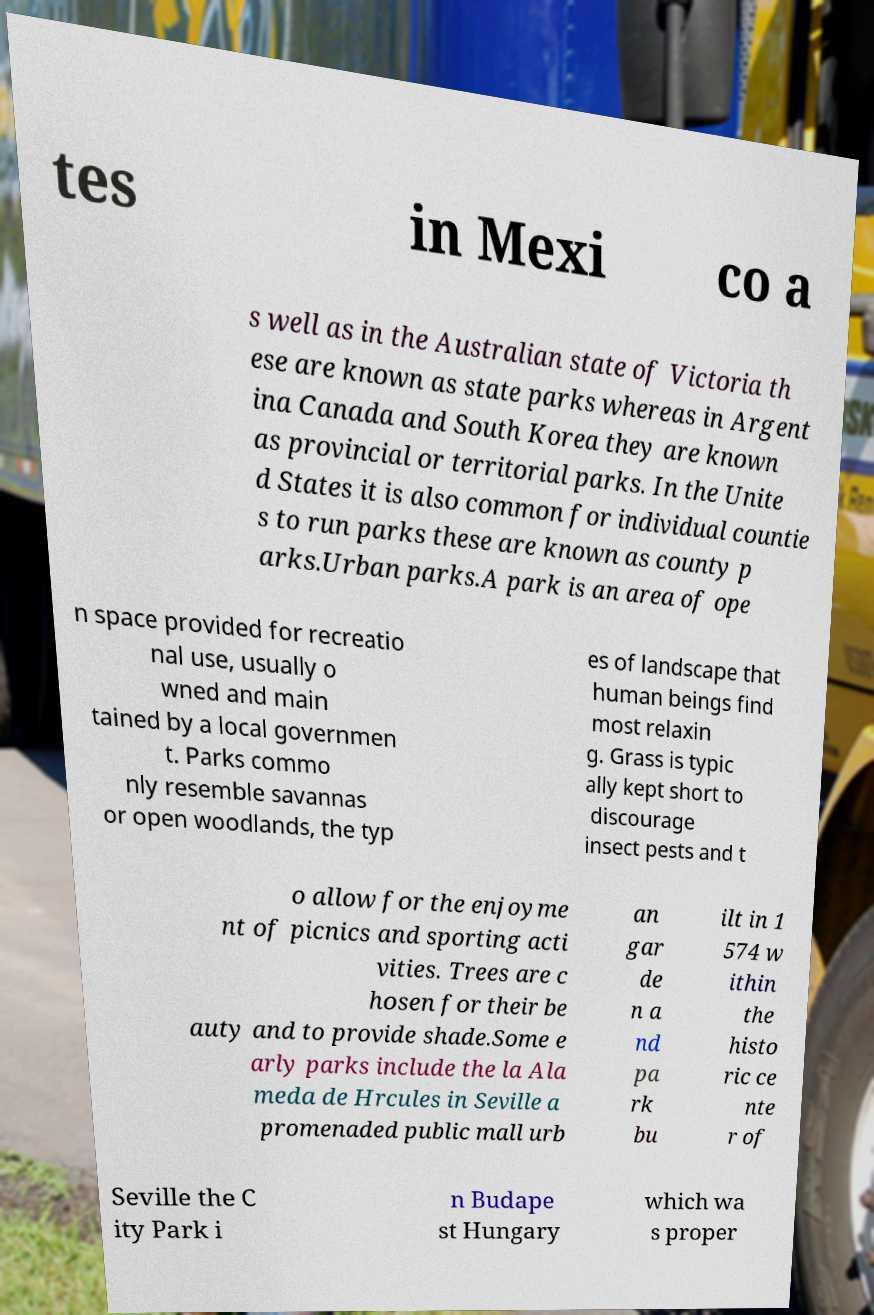For documentation purposes, I need the text within this image transcribed. Could you provide that? tes in Mexi co a s well as in the Australian state of Victoria th ese are known as state parks whereas in Argent ina Canada and South Korea they are known as provincial or territorial parks. In the Unite d States it is also common for individual countie s to run parks these are known as county p arks.Urban parks.A park is an area of ope n space provided for recreatio nal use, usually o wned and main tained by a local governmen t. Parks commo nly resemble savannas or open woodlands, the typ es of landscape that human beings find most relaxin g. Grass is typic ally kept short to discourage insect pests and t o allow for the enjoyme nt of picnics and sporting acti vities. Trees are c hosen for their be auty and to provide shade.Some e arly parks include the la Ala meda de Hrcules in Seville a promenaded public mall urb an gar de n a nd pa rk bu ilt in 1 574 w ithin the histo ric ce nte r of Seville the C ity Park i n Budape st Hungary which wa s proper 